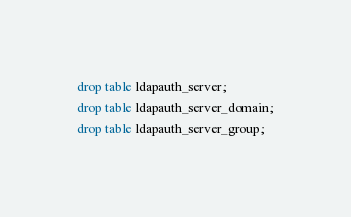Convert code to text. <code><loc_0><loc_0><loc_500><loc_500><_SQL_>drop table ldapauth_server;
drop table ldapauth_server_domain;
drop table ldapauth_server_group;</code> 